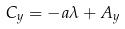<formula> <loc_0><loc_0><loc_500><loc_500>C _ { y } = - a \lambda + A _ { y }</formula> 